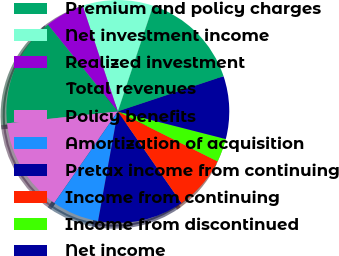<chart> <loc_0><loc_0><loc_500><loc_500><pie_chart><fcel>Premium and policy charges<fcel>Net investment income<fcel>Realized investment<fcel>Total revenues<fcel>Policy benefits<fcel>Amortization of acquisition<fcel>Pretax income from continuing<fcel>Income from continuing<fcel>Income from discontinued<fcel>Net income<nl><fcel>14.77%<fcel>10.23%<fcel>5.68%<fcel>15.91%<fcel>13.64%<fcel>6.82%<fcel>12.5%<fcel>7.95%<fcel>3.41%<fcel>9.09%<nl></chart> 